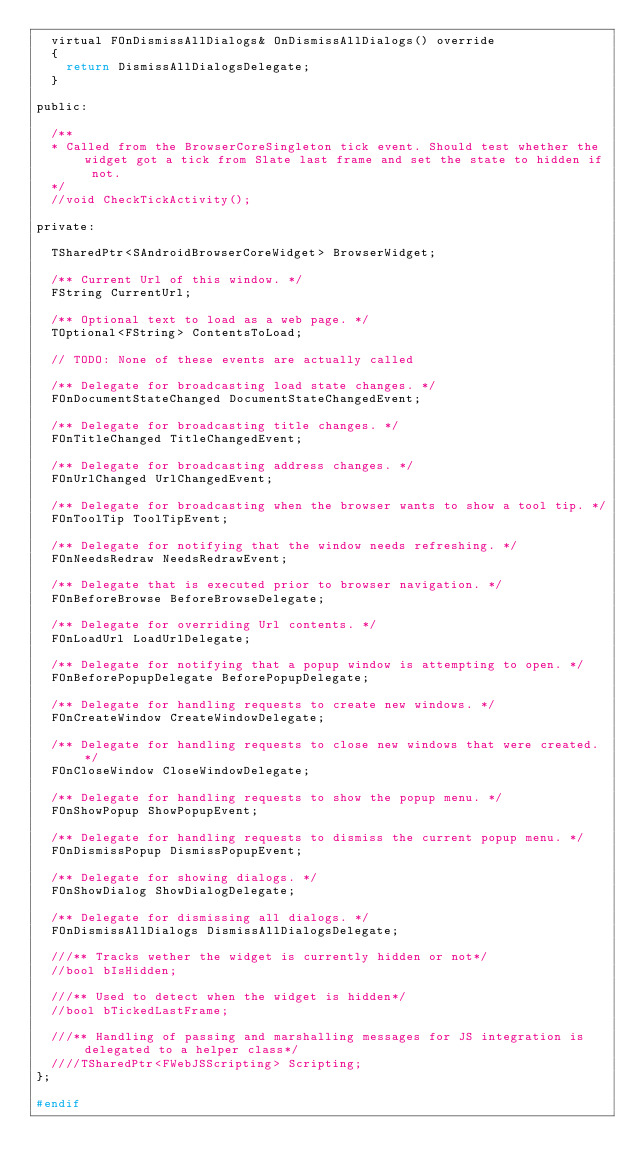Convert code to text. <code><loc_0><loc_0><loc_500><loc_500><_C_>	virtual FOnDismissAllDialogs& OnDismissAllDialogs() override
	{
		return DismissAllDialogsDelegate;
	}

public:

	/**
	* Called from the BrowserCoreSingleton tick event. Should test whether the widget got a tick from Slate last frame and set the state to hidden if not.
	*/
	//void CheckTickActivity();

private:

	TSharedPtr<SAndroidBrowserCoreWidget> BrowserWidget;

	/** Current Url of this window. */
	FString CurrentUrl;

	/** Optional text to load as a web page. */
	TOptional<FString> ContentsToLoad;

	// TODO: None of these events are actually called

	/** Delegate for broadcasting load state changes. */
	FOnDocumentStateChanged DocumentStateChangedEvent;

	/** Delegate for broadcasting title changes. */
	FOnTitleChanged TitleChangedEvent;

	/** Delegate for broadcasting address changes. */
	FOnUrlChanged UrlChangedEvent;

	/** Delegate for broadcasting when the browser wants to show a tool tip. */
	FOnToolTip ToolTipEvent;

	/** Delegate for notifying that the window needs refreshing. */
	FOnNeedsRedraw NeedsRedrawEvent;

	/** Delegate that is executed prior to browser navigation. */
	FOnBeforeBrowse BeforeBrowseDelegate;

	/** Delegate for overriding Url contents. */
	FOnLoadUrl LoadUrlDelegate;

	/** Delegate for notifying that a popup window is attempting to open. */
	FOnBeforePopupDelegate BeforePopupDelegate;

	/** Delegate for handling requests to create new windows. */
	FOnCreateWindow CreateWindowDelegate;

	/** Delegate for handling requests to close new windows that were created. */
	FOnCloseWindow CloseWindowDelegate;

	/** Delegate for handling requests to show the popup menu. */
	FOnShowPopup ShowPopupEvent;

	/** Delegate for handling requests to dismiss the current popup menu. */
	FOnDismissPopup DismissPopupEvent;

	/** Delegate for showing dialogs. */
	FOnShowDialog ShowDialogDelegate;

	/** Delegate for dismissing all dialogs. */
	FOnDismissAllDialogs DismissAllDialogsDelegate;

	///** Tracks wether the widget is currently hidden or not*/
	//bool bIsHidden;

	///** Used to detect when the widget is hidden*/
	//bool bTickedLastFrame;

	///** Handling of passing and marshalling messages for JS integration is delegated to a helper class*/
	////TSharedPtr<FWebJSScripting> Scripting;
};

#endif
</code> 